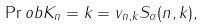Convert formula to latex. <formula><loc_0><loc_0><loc_500><loc_500>\Pr o b { K _ { n } = k } = v _ { n , k } S _ { \alpha } ( n , k ) ,</formula> 